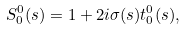Convert formula to latex. <formula><loc_0><loc_0><loc_500><loc_500>S _ { 0 } ^ { 0 } ( s ) = 1 + 2 i \sigma ( s ) t _ { 0 } ^ { 0 } ( s ) ,</formula> 